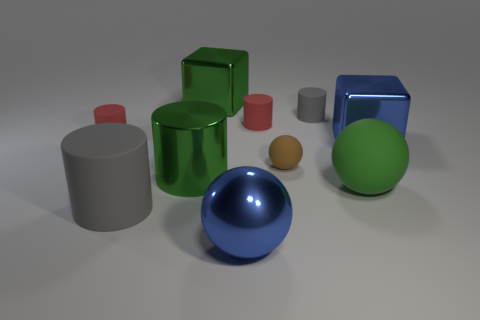There is a big object that is behind the brown rubber ball and on the right side of the small brown matte object; what is its material?
Provide a succinct answer. Metal. What material is the blue thing that is the same shape as the tiny brown matte object?
Make the answer very short. Metal. There is a small thing that is left of the metallic cube on the left side of the tiny brown matte ball; what number of red matte things are on the left side of it?
Give a very brief answer. 0. Is there any other thing that is the same color as the shiny cylinder?
Ensure brevity in your answer.  Yes. How many rubber cylinders are behind the metal cylinder and to the left of the blue metal sphere?
Provide a short and direct response. 1. Is the size of the blue metal object right of the large green matte ball the same as the ball that is in front of the green sphere?
Your answer should be very brief. Yes. What number of things are either red rubber cylinders right of the large green block or large green matte spheres?
Offer a very short reply. 2. There is a gray cylinder to the left of the tiny brown thing; what material is it?
Give a very brief answer. Rubber. What is the material of the brown thing?
Your answer should be compact. Rubber. There is a tiny thing to the left of the large sphere to the left of the green thing on the right side of the tiny brown matte object; what is it made of?
Your answer should be compact. Rubber. 